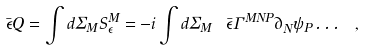<formula> <loc_0><loc_0><loc_500><loc_500>\bar { \epsilon } Q = \int d \Sigma _ { M } S ^ { M } _ { \epsilon } = - i \int d \Sigma _ { M } \ \bar { \epsilon } \Gamma ^ { M N P } \partial _ { N } \psi _ { P } \dots \ ,</formula> 